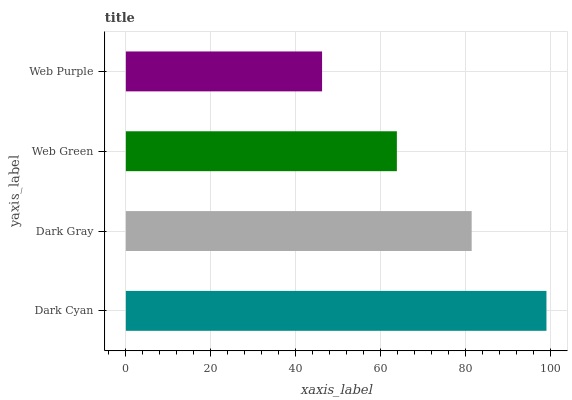Is Web Purple the minimum?
Answer yes or no. Yes. Is Dark Cyan the maximum?
Answer yes or no. Yes. Is Dark Gray the minimum?
Answer yes or no. No. Is Dark Gray the maximum?
Answer yes or no. No. Is Dark Cyan greater than Dark Gray?
Answer yes or no. Yes. Is Dark Gray less than Dark Cyan?
Answer yes or no. Yes. Is Dark Gray greater than Dark Cyan?
Answer yes or no. No. Is Dark Cyan less than Dark Gray?
Answer yes or no. No. Is Dark Gray the high median?
Answer yes or no. Yes. Is Web Green the low median?
Answer yes or no. Yes. Is Web Purple the high median?
Answer yes or no. No. Is Dark Cyan the low median?
Answer yes or no. No. 